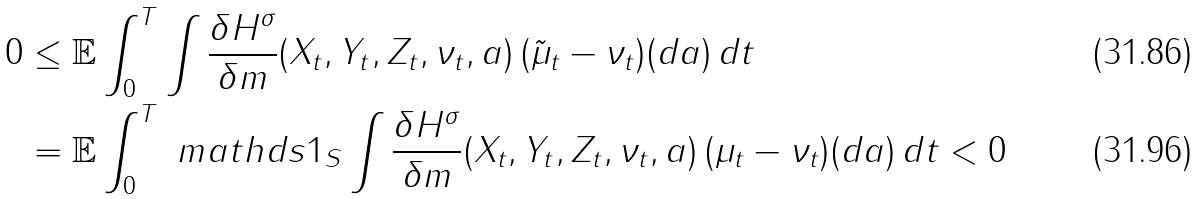Convert formula to latex. <formula><loc_0><loc_0><loc_500><loc_500>0 & \leq \mathbb { E } \int _ { 0 } ^ { T } \int \frac { \delta H ^ { \sigma } } { \delta m } ( X _ { t } , Y _ { t } , Z _ { t } , \nu _ { t } , a ) \, ( \tilde { \mu } _ { t } - \nu _ { t } ) ( d a ) \, d t \\ & = \mathbb { E } \int _ { 0 } ^ { T } \ m a t h d s { 1 } _ { S } \int \frac { \delta H ^ { \sigma } } { \delta m } ( X _ { t } , Y _ { t } , Z _ { t } , \nu _ { t } , a ) \, ( \mu _ { t } - \nu _ { t } ) ( d a ) \, d t < 0</formula> 